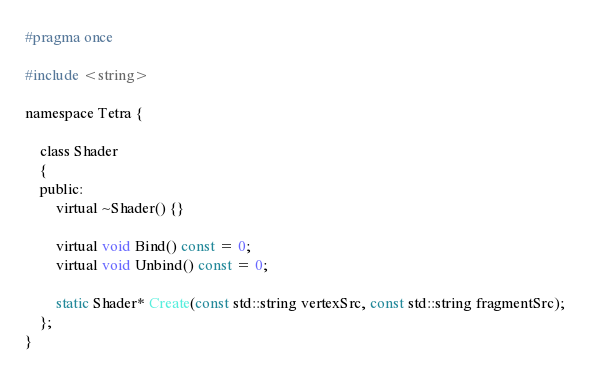Convert code to text. <code><loc_0><loc_0><loc_500><loc_500><_C_>#pragma once

#include <string>

namespace Tetra {

	class Shader
	{
	public:
		virtual ~Shader() {}

		virtual void Bind() const = 0;
		virtual void Unbind() const = 0;

		static Shader* Create(const std::string vertexSrc, const std::string fragmentSrc);
	};
}</code> 